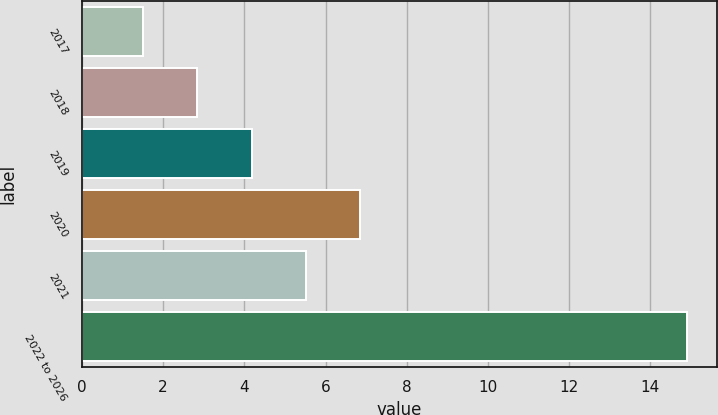Convert chart. <chart><loc_0><loc_0><loc_500><loc_500><bar_chart><fcel>2017<fcel>2018<fcel>2019<fcel>2020<fcel>2021<fcel>2022 to 2026<nl><fcel>1.5<fcel>2.84<fcel>4.18<fcel>6.86<fcel>5.52<fcel>14.9<nl></chart> 